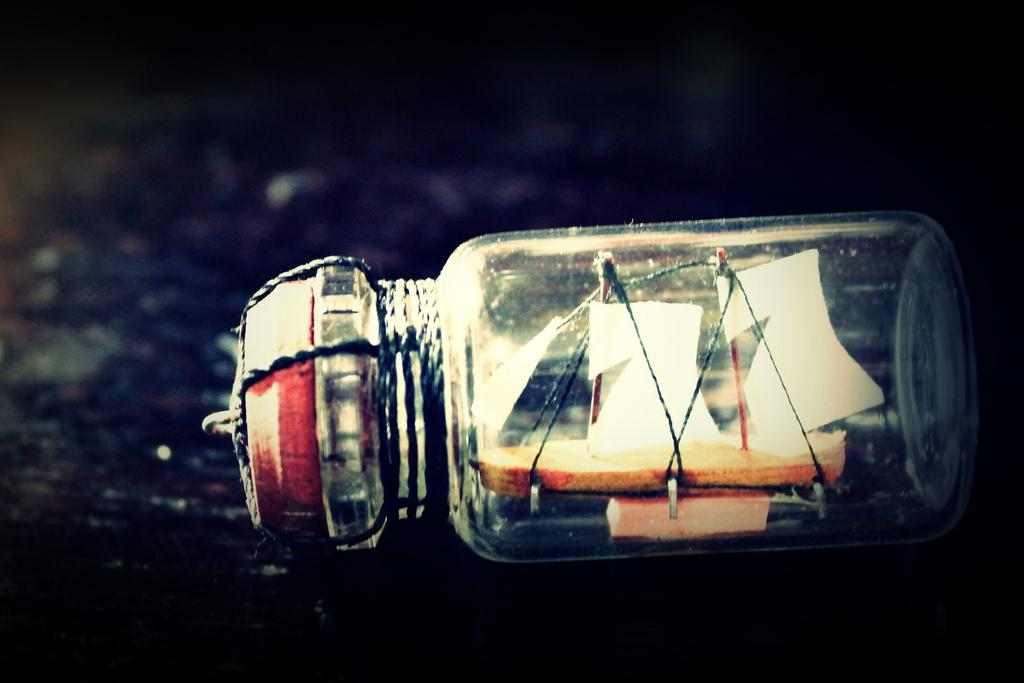What is inside the bottle in the image? There is a miniature ship inside the bottle. How is the bottle secured or attached in the image? The bottle is tied with a thread. Where is the bottle located in the image? The bottle is placed on a surface. What type of straw is used to create the sails of the ship in the image? There is no straw present in the image; the ship is a miniature model inside a bottle. 